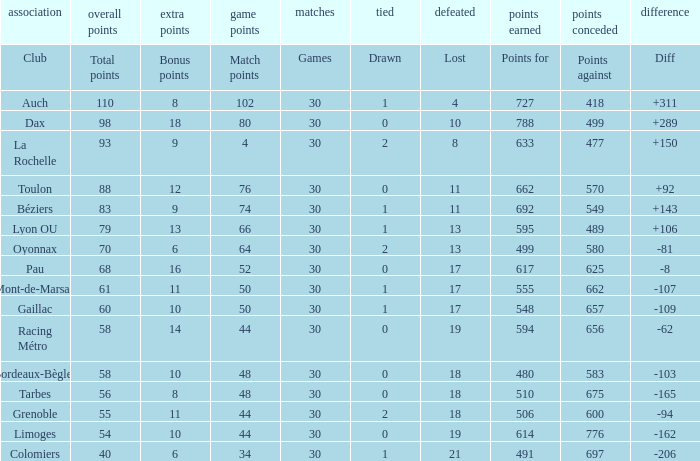What is the diff for a club that has a value of 662 for points for? 92.0. 